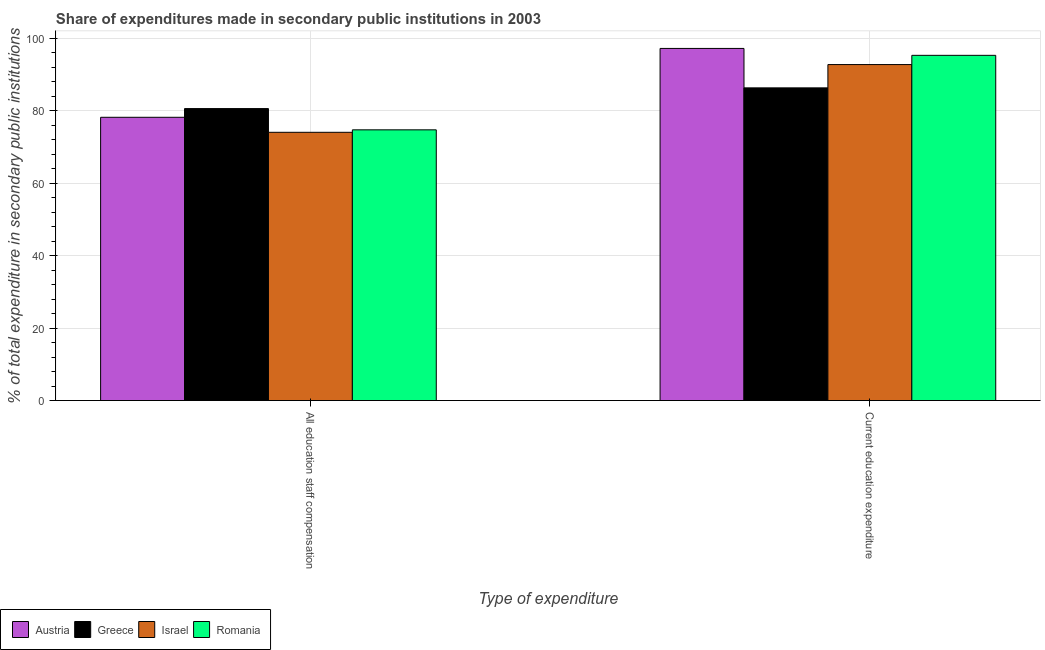How many groups of bars are there?
Keep it short and to the point. 2. Are the number of bars per tick equal to the number of legend labels?
Provide a short and direct response. Yes. What is the label of the 1st group of bars from the left?
Make the answer very short. All education staff compensation. What is the expenditure in education in Austria?
Give a very brief answer. 97.22. Across all countries, what is the maximum expenditure in staff compensation?
Provide a short and direct response. 80.61. Across all countries, what is the minimum expenditure in education?
Ensure brevity in your answer.  86.33. In which country was the expenditure in staff compensation minimum?
Provide a short and direct response. Israel. What is the total expenditure in staff compensation in the graph?
Offer a very short reply. 307.64. What is the difference between the expenditure in education in Greece and that in Austria?
Your response must be concise. -10.89. What is the difference between the expenditure in staff compensation in Israel and the expenditure in education in Austria?
Make the answer very short. -23.15. What is the average expenditure in staff compensation per country?
Your response must be concise. 76.91. What is the difference between the expenditure in staff compensation and expenditure in education in Israel?
Your response must be concise. -18.7. In how many countries, is the expenditure in education greater than 40 %?
Your response must be concise. 4. What is the ratio of the expenditure in education in Greece to that in Israel?
Ensure brevity in your answer.  0.93. What does the 1st bar from the right in Current education expenditure represents?
Offer a very short reply. Romania. How many countries are there in the graph?
Provide a succinct answer. 4. What is the difference between two consecutive major ticks on the Y-axis?
Make the answer very short. 20. Are the values on the major ticks of Y-axis written in scientific E-notation?
Ensure brevity in your answer.  No. Does the graph contain any zero values?
Ensure brevity in your answer.  No. Does the graph contain grids?
Ensure brevity in your answer.  Yes. Where does the legend appear in the graph?
Keep it short and to the point. Bottom left. How are the legend labels stacked?
Offer a terse response. Horizontal. What is the title of the graph?
Your answer should be very brief. Share of expenditures made in secondary public institutions in 2003. What is the label or title of the X-axis?
Offer a very short reply. Type of expenditure. What is the label or title of the Y-axis?
Keep it short and to the point. % of total expenditure in secondary public institutions. What is the % of total expenditure in secondary public institutions of Austria in All education staff compensation?
Your answer should be compact. 78.21. What is the % of total expenditure in secondary public institutions of Greece in All education staff compensation?
Provide a short and direct response. 80.61. What is the % of total expenditure in secondary public institutions of Israel in All education staff compensation?
Give a very brief answer. 74.07. What is the % of total expenditure in secondary public institutions of Romania in All education staff compensation?
Offer a very short reply. 74.75. What is the % of total expenditure in secondary public institutions of Austria in Current education expenditure?
Keep it short and to the point. 97.22. What is the % of total expenditure in secondary public institutions of Greece in Current education expenditure?
Your answer should be very brief. 86.33. What is the % of total expenditure in secondary public institutions of Israel in Current education expenditure?
Provide a succinct answer. 92.77. What is the % of total expenditure in secondary public institutions of Romania in Current education expenditure?
Your response must be concise. 95.31. Across all Type of expenditure, what is the maximum % of total expenditure in secondary public institutions of Austria?
Make the answer very short. 97.22. Across all Type of expenditure, what is the maximum % of total expenditure in secondary public institutions in Greece?
Your answer should be very brief. 86.33. Across all Type of expenditure, what is the maximum % of total expenditure in secondary public institutions of Israel?
Ensure brevity in your answer.  92.77. Across all Type of expenditure, what is the maximum % of total expenditure in secondary public institutions in Romania?
Your answer should be compact. 95.31. Across all Type of expenditure, what is the minimum % of total expenditure in secondary public institutions of Austria?
Offer a terse response. 78.21. Across all Type of expenditure, what is the minimum % of total expenditure in secondary public institutions of Greece?
Your answer should be compact. 80.61. Across all Type of expenditure, what is the minimum % of total expenditure in secondary public institutions in Israel?
Provide a succinct answer. 74.07. Across all Type of expenditure, what is the minimum % of total expenditure in secondary public institutions in Romania?
Keep it short and to the point. 74.75. What is the total % of total expenditure in secondary public institutions in Austria in the graph?
Ensure brevity in your answer.  175.43. What is the total % of total expenditure in secondary public institutions of Greece in the graph?
Make the answer very short. 166.95. What is the total % of total expenditure in secondary public institutions in Israel in the graph?
Provide a short and direct response. 166.83. What is the total % of total expenditure in secondary public institutions of Romania in the graph?
Make the answer very short. 170.06. What is the difference between the % of total expenditure in secondary public institutions of Austria in All education staff compensation and that in Current education expenditure?
Ensure brevity in your answer.  -19.01. What is the difference between the % of total expenditure in secondary public institutions in Greece in All education staff compensation and that in Current education expenditure?
Your answer should be compact. -5.72. What is the difference between the % of total expenditure in secondary public institutions in Israel in All education staff compensation and that in Current education expenditure?
Provide a succinct answer. -18.7. What is the difference between the % of total expenditure in secondary public institutions of Romania in All education staff compensation and that in Current education expenditure?
Make the answer very short. -20.56. What is the difference between the % of total expenditure in secondary public institutions in Austria in All education staff compensation and the % of total expenditure in secondary public institutions in Greece in Current education expenditure?
Your answer should be very brief. -8.12. What is the difference between the % of total expenditure in secondary public institutions of Austria in All education staff compensation and the % of total expenditure in secondary public institutions of Israel in Current education expenditure?
Provide a short and direct response. -14.55. What is the difference between the % of total expenditure in secondary public institutions in Austria in All education staff compensation and the % of total expenditure in secondary public institutions in Romania in Current education expenditure?
Your answer should be very brief. -17.1. What is the difference between the % of total expenditure in secondary public institutions of Greece in All education staff compensation and the % of total expenditure in secondary public institutions of Israel in Current education expenditure?
Your answer should be very brief. -12.15. What is the difference between the % of total expenditure in secondary public institutions in Greece in All education staff compensation and the % of total expenditure in secondary public institutions in Romania in Current education expenditure?
Make the answer very short. -14.7. What is the difference between the % of total expenditure in secondary public institutions in Israel in All education staff compensation and the % of total expenditure in secondary public institutions in Romania in Current education expenditure?
Ensure brevity in your answer.  -21.25. What is the average % of total expenditure in secondary public institutions of Austria per Type of expenditure?
Offer a terse response. 87.72. What is the average % of total expenditure in secondary public institutions of Greece per Type of expenditure?
Provide a succinct answer. 83.47. What is the average % of total expenditure in secondary public institutions in Israel per Type of expenditure?
Offer a terse response. 83.42. What is the average % of total expenditure in secondary public institutions of Romania per Type of expenditure?
Ensure brevity in your answer.  85.03. What is the difference between the % of total expenditure in secondary public institutions in Austria and % of total expenditure in secondary public institutions in Greece in All education staff compensation?
Give a very brief answer. -2.4. What is the difference between the % of total expenditure in secondary public institutions of Austria and % of total expenditure in secondary public institutions of Israel in All education staff compensation?
Ensure brevity in your answer.  4.15. What is the difference between the % of total expenditure in secondary public institutions of Austria and % of total expenditure in secondary public institutions of Romania in All education staff compensation?
Give a very brief answer. 3.46. What is the difference between the % of total expenditure in secondary public institutions in Greece and % of total expenditure in secondary public institutions in Israel in All education staff compensation?
Offer a terse response. 6.55. What is the difference between the % of total expenditure in secondary public institutions of Greece and % of total expenditure in secondary public institutions of Romania in All education staff compensation?
Keep it short and to the point. 5.86. What is the difference between the % of total expenditure in secondary public institutions of Israel and % of total expenditure in secondary public institutions of Romania in All education staff compensation?
Provide a succinct answer. -0.68. What is the difference between the % of total expenditure in secondary public institutions of Austria and % of total expenditure in secondary public institutions of Greece in Current education expenditure?
Make the answer very short. 10.89. What is the difference between the % of total expenditure in secondary public institutions in Austria and % of total expenditure in secondary public institutions in Israel in Current education expenditure?
Provide a short and direct response. 4.45. What is the difference between the % of total expenditure in secondary public institutions of Austria and % of total expenditure in secondary public institutions of Romania in Current education expenditure?
Offer a terse response. 1.91. What is the difference between the % of total expenditure in secondary public institutions in Greece and % of total expenditure in secondary public institutions in Israel in Current education expenditure?
Keep it short and to the point. -6.43. What is the difference between the % of total expenditure in secondary public institutions of Greece and % of total expenditure in secondary public institutions of Romania in Current education expenditure?
Provide a succinct answer. -8.98. What is the difference between the % of total expenditure in secondary public institutions in Israel and % of total expenditure in secondary public institutions in Romania in Current education expenditure?
Make the answer very short. -2.55. What is the ratio of the % of total expenditure in secondary public institutions in Austria in All education staff compensation to that in Current education expenditure?
Offer a very short reply. 0.8. What is the ratio of the % of total expenditure in secondary public institutions in Greece in All education staff compensation to that in Current education expenditure?
Make the answer very short. 0.93. What is the ratio of the % of total expenditure in secondary public institutions in Israel in All education staff compensation to that in Current education expenditure?
Offer a terse response. 0.8. What is the ratio of the % of total expenditure in secondary public institutions of Romania in All education staff compensation to that in Current education expenditure?
Your answer should be very brief. 0.78. What is the difference between the highest and the second highest % of total expenditure in secondary public institutions in Austria?
Keep it short and to the point. 19.01. What is the difference between the highest and the second highest % of total expenditure in secondary public institutions in Greece?
Ensure brevity in your answer.  5.72. What is the difference between the highest and the second highest % of total expenditure in secondary public institutions of Israel?
Your answer should be very brief. 18.7. What is the difference between the highest and the second highest % of total expenditure in secondary public institutions in Romania?
Offer a terse response. 20.56. What is the difference between the highest and the lowest % of total expenditure in secondary public institutions of Austria?
Give a very brief answer. 19.01. What is the difference between the highest and the lowest % of total expenditure in secondary public institutions of Greece?
Your answer should be very brief. 5.72. What is the difference between the highest and the lowest % of total expenditure in secondary public institutions in Israel?
Your answer should be very brief. 18.7. What is the difference between the highest and the lowest % of total expenditure in secondary public institutions in Romania?
Your response must be concise. 20.56. 